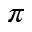Convert formula to latex. <formula><loc_0><loc_0><loc_500><loc_500>\pi</formula> 